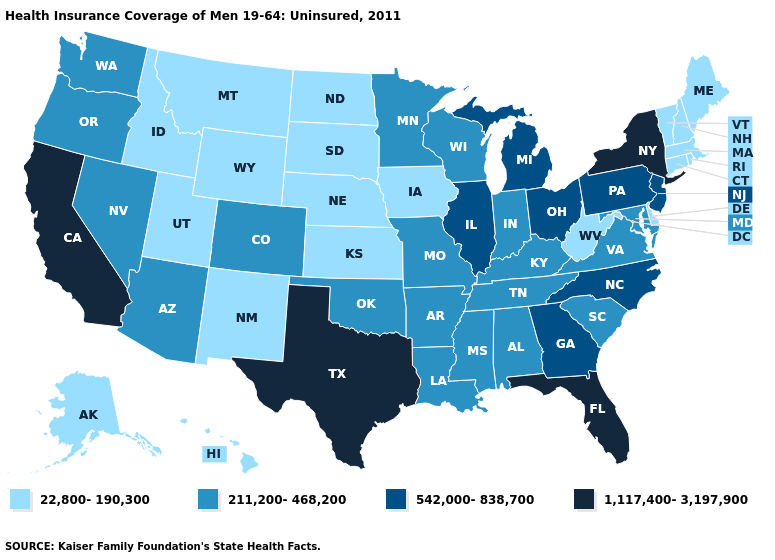Does the first symbol in the legend represent the smallest category?
Write a very short answer. Yes. What is the value of Oklahoma?
Short answer required. 211,200-468,200. Which states hav the highest value in the Northeast?
Answer briefly. New York. Which states have the highest value in the USA?
Short answer required. California, Florida, New York, Texas. Which states have the highest value in the USA?
Concise answer only. California, Florida, New York, Texas. What is the lowest value in states that border Oregon?
Quick response, please. 22,800-190,300. Which states have the lowest value in the MidWest?
Be succinct. Iowa, Kansas, Nebraska, North Dakota, South Dakota. Name the states that have a value in the range 22,800-190,300?
Write a very short answer. Alaska, Connecticut, Delaware, Hawaii, Idaho, Iowa, Kansas, Maine, Massachusetts, Montana, Nebraska, New Hampshire, New Mexico, North Dakota, Rhode Island, South Dakota, Utah, Vermont, West Virginia, Wyoming. Which states hav the highest value in the Northeast?
Write a very short answer. New York. How many symbols are there in the legend?
Quick response, please. 4. Is the legend a continuous bar?
Give a very brief answer. No. Which states have the lowest value in the USA?
Give a very brief answer. Alaska, Connecticut, Delaware, Hawaii, Idaho, Iowa, Kansas, Maine, Massachusetts, Montana, Nebraska, New Hampshire, New Mexico, North Dakota, Rhode Island, South Dakota, Utah, Vermont, West Virginia, Wyoming. Which states have the lowest value in the West?
Write a very short answer. Alaska, Hawaii, Idaho, Montana, New Mexico, Utah, Wyoming. Name the states that have a value in the range 211,200-468,200?
Answer briefly. Alabama, Arizona, Arkansas, Colorado, Indiana, Kentucky, Louisiana, Maryland, Minnesota, Mississippi, Missouri, Nevada, Oklahoma, Oregon, South Carolina, Tennessee, Virginia, Washington, Wisconsin. 